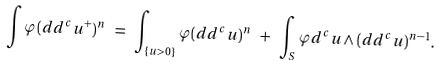<formula> <loc_0><loc_0><loc_500><loc_500>\int \varphi ( d d ^ { c } u ^ { + } ) ^ { n } \ = \ \int _ { \{ u > 0 \} } \varphi ( d d ^ { c } u ) ^ { n } \ + \ \int _ { S } \varphi d ^ { c } u \wedge ( d d ^ { c } u ) ^ { n - 1 } .</formula> 